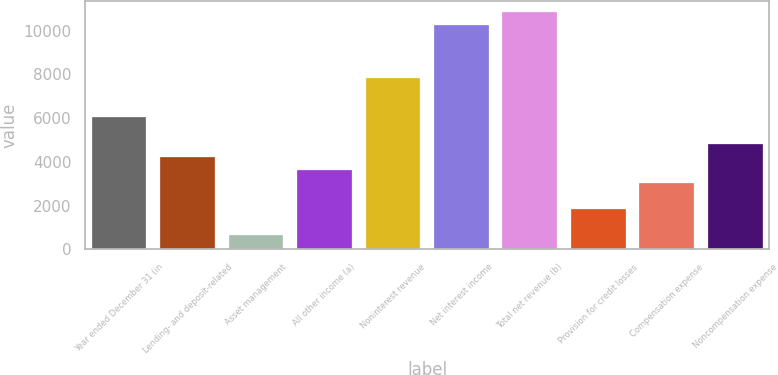Convert chart to OTSL. <chart><loc_0><loc_0><loc_500><loc_500><bar_chart><fcel>Year ended December 31 (in<fcel>Lending- and deposit-related<fcel>Asset management<fcel>All other income (a)<fcel>Noninterest revenue<fcel>Net interest income<fcel>Total net revenue (b)<fcel>Provision for credit losses<fcel>Compensation expense<fcel>Noncompensation expense<nl><fcel>6040<fcel>4238.5<fcel>635.5<fcel>3638<fcel>7841.5<fcel>10243.5<fcel>10844<fcel>1836.5<fcel>3037.5<fcel>4839<nl></chart> 